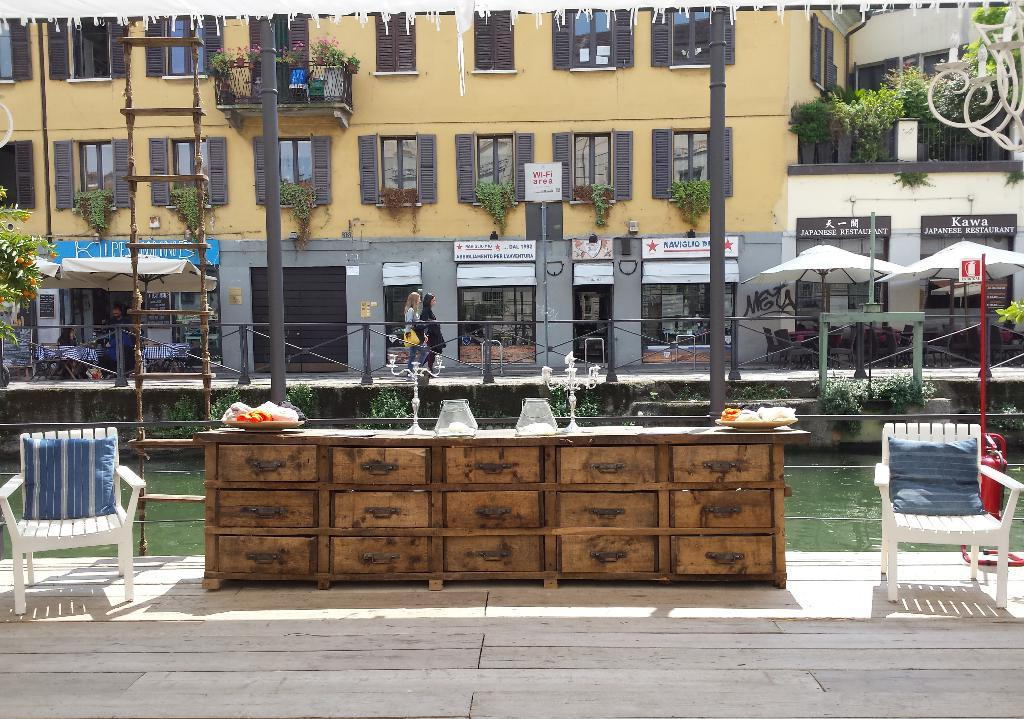What type of structure is present in the image? There is a building in the image. What other elements can be seen in the image besides the building? There are plants, umbrellas, a canal, a table, and two chairs in the image. What might be used for providing shade in the image? The umbrellas in the image can be used for providing shade. What is the purpose of the table and chairs in the image? The table and chairs in the image might be used for sitting and dining. What type of gold development can be seen in the image? There is no gold development present in the image. The image features a building, plants, umbrellas, a canal, a table, and two chairs. 